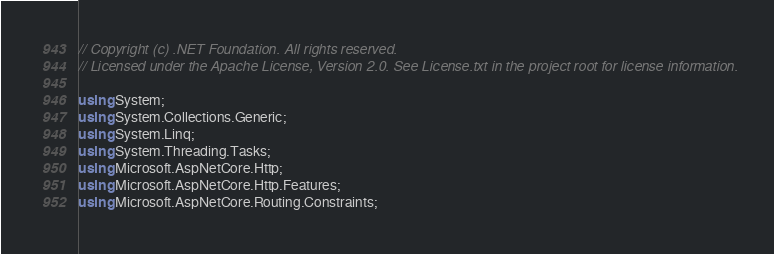Convert code to text. <code><loc_0><loc_0><loc_500><loc_500><_C#_>// Copyright (c) .NET Foundation. All rights reserved.
// Licensed under the Apache License, Version 2.0. See License.txt in the project root for license information.

using System;
using System.Collections.Generic;
using System.Linq;
using System.Threading.Tasks;
using Microsoft.AspNetCore.Http;
using Microsoft.AspNetCore.Http.Features;
using Microsoft.AspNetCore.Routing.Constraints;</code> 